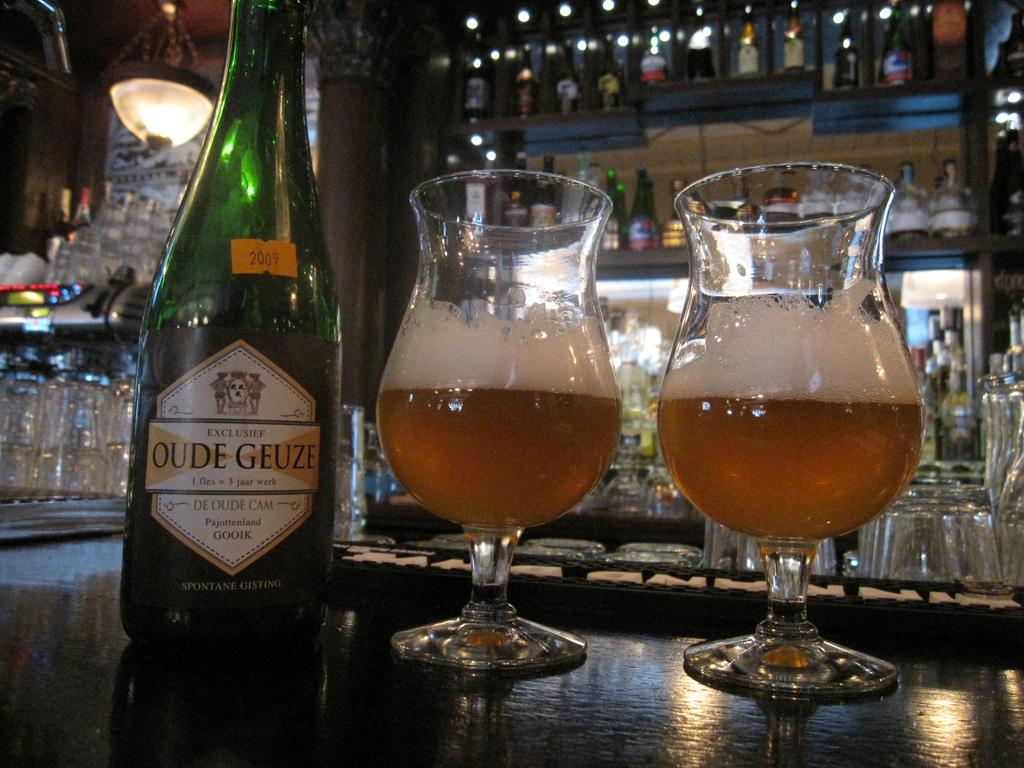Provide a one-sentence caption for the provided image. A bottle of Oude Geuze is next to two glasses with the ale inside. 